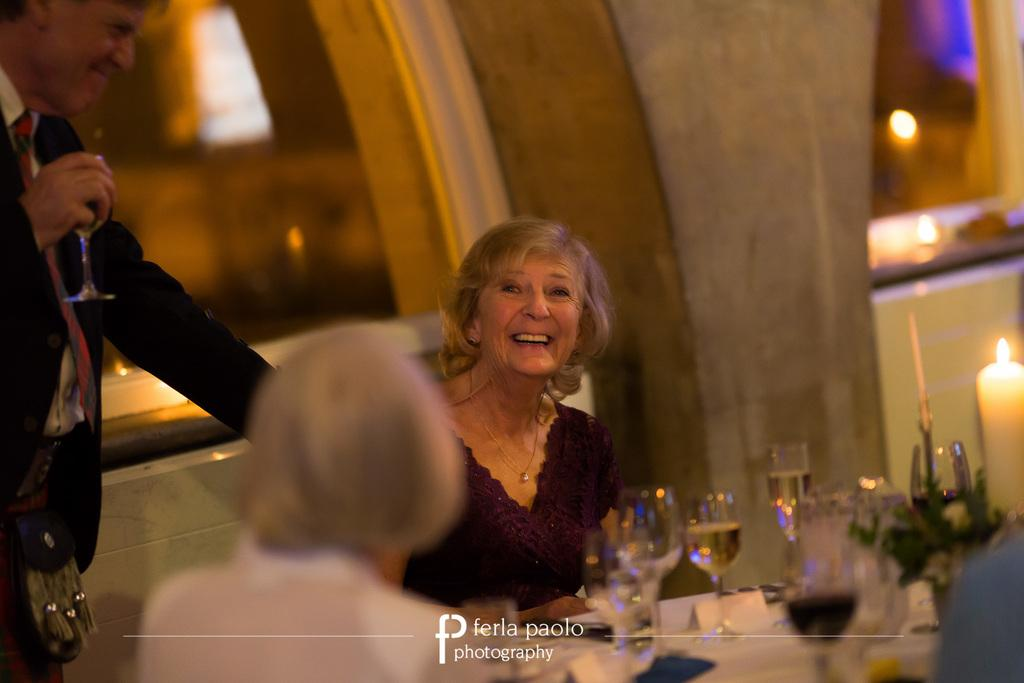What are the people in the image doing? The people in the image are sitting. What is one person holding in the image? One person is holding a glass. What can be seen on the table in the image? There are glasses, a candle, and other objects on the table. How would you describe the background of the image? The background of the image is blurred. What type of vessel is the mailbox used for in the image? There is no mailbox present in the image. Can you describe the color of the person's toe in the image? There is no mention of a person's toe in the image, and therefore no color can be described. 